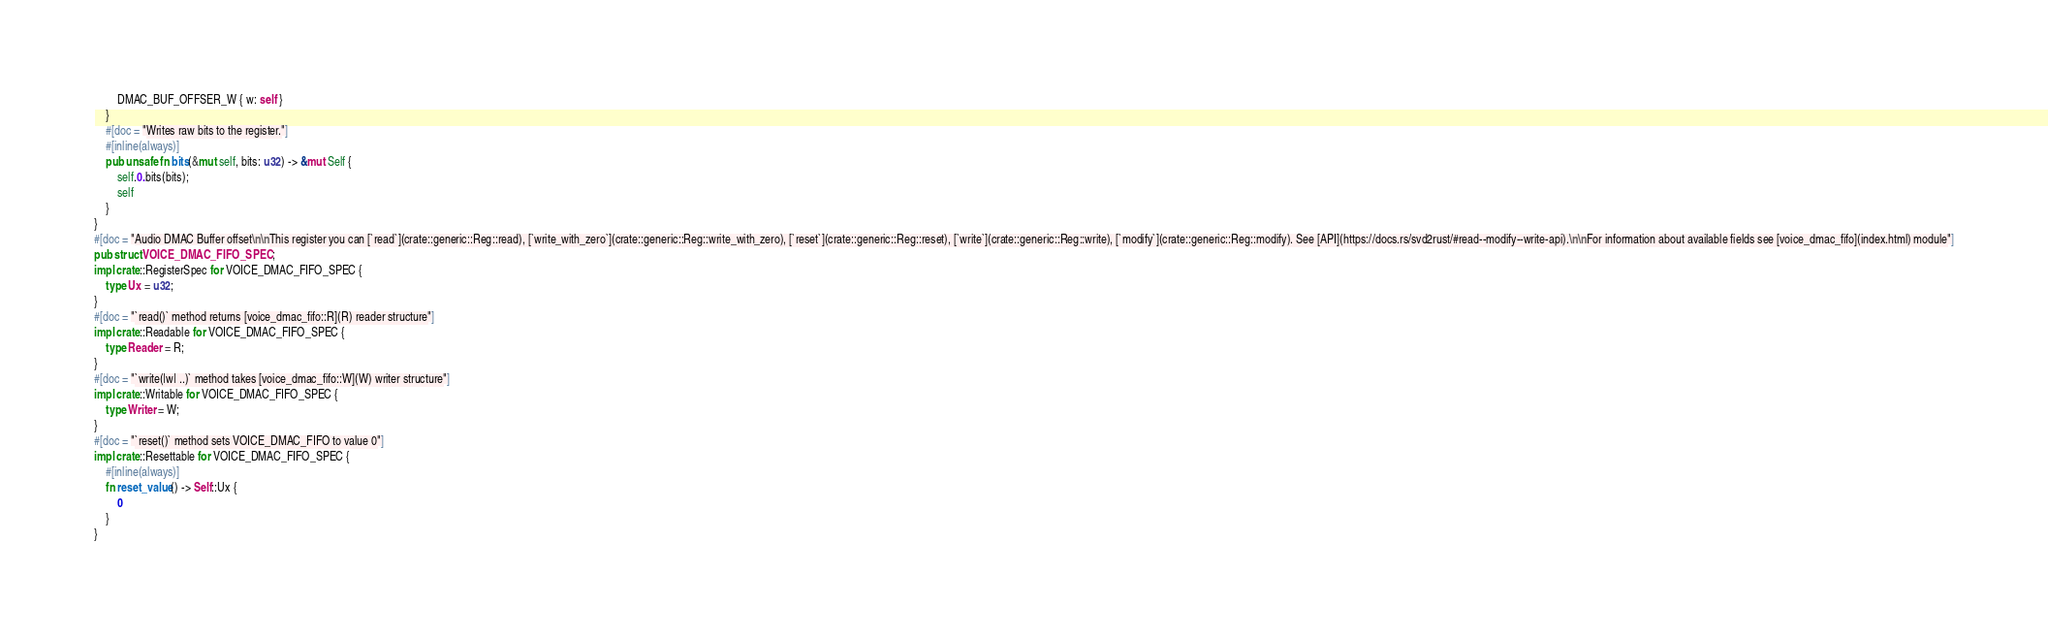Convert code to text. <code><loc_0><loc_0><loc_500><loc_500><_Rust_>        DMAC_BUF_OFFSER_W { w: self }
    }
    #[doc = "Writes raw bits to the register."]
    #[inline(always)]
    pub unsafe fn bits(&mut self, bits: u32) -> &mut Self {
        self.0.bits(bits);
        self
    }
}
#[doc = "Audio DMAC Buffer offset\n\nThis register you can [`read`](crate::generic::Reg::read), [`write_with_zero`](crate::generic::Reg::write_with_zero), [`reset`](crate::generic::Reg::reset), [`write`](crate::generic::Reg::write), [`modify`](crate::generic::Reg::modify). See [API](https://docs.rs/svd2rust/#read--modify--write-api).\n\nFor information about available fields see [voice_dmac_fifo](index.html) module"]
pub struct VOICE_DMAC_FIFO_SPEC;
impl crate::RegisterSpec for VOICE_DMAC_FIFO_SPEC {
    type Ux = u32;
}
#[doc = "`read()` method returns [voice_dmac_fifo::R](R) reader structure"]
impl crate::Readable for VOICE_DMAC_FIFO_SPEC {
    type Reader = R;
}
#[doc = "`write(|w| ..)` method takes [voice_dmac_fifo::W](W) writer structure"]
impl crate::Writable for VOICE_DMAC_FIFO_SPEC {
    type Writer = W;
}
#[doc = "`reset()` method sets VOICE_DMAC_FIFO to value 0"]
impl crate::Resettable for VOICE_DMAC_FIFO_SPEC {
    #[inline(always)]
    fn reset_value() -> Self::Ux {
        0
    }
}
</code> 